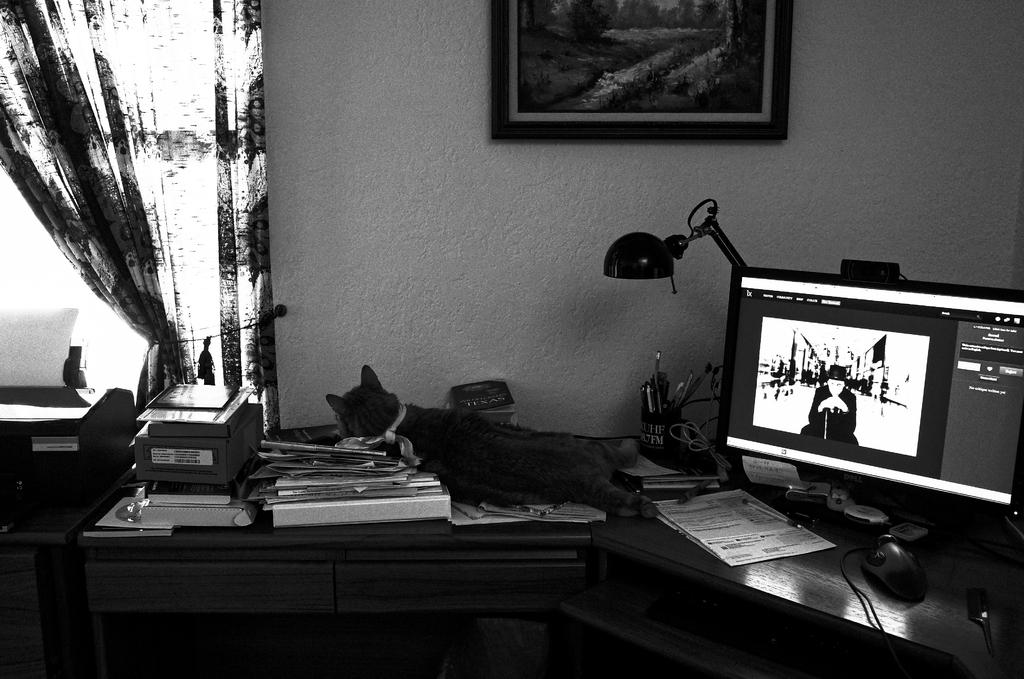What is the color scheme of the image? The picture is black and white. Where is the picture located in the scene? The picture is on the wall. What can be seen in the image? There is a curtain in the image. How many roses are on the table in the image? There are no roses present on the table in the image. What type of house is depicted in the image? The image does not depict a house; it is a picture on the wall with a curtain visible. What level of respect is shown by the objects in the image? The objects in the image do not display respect or any other emotions; they are inanimate objects. 